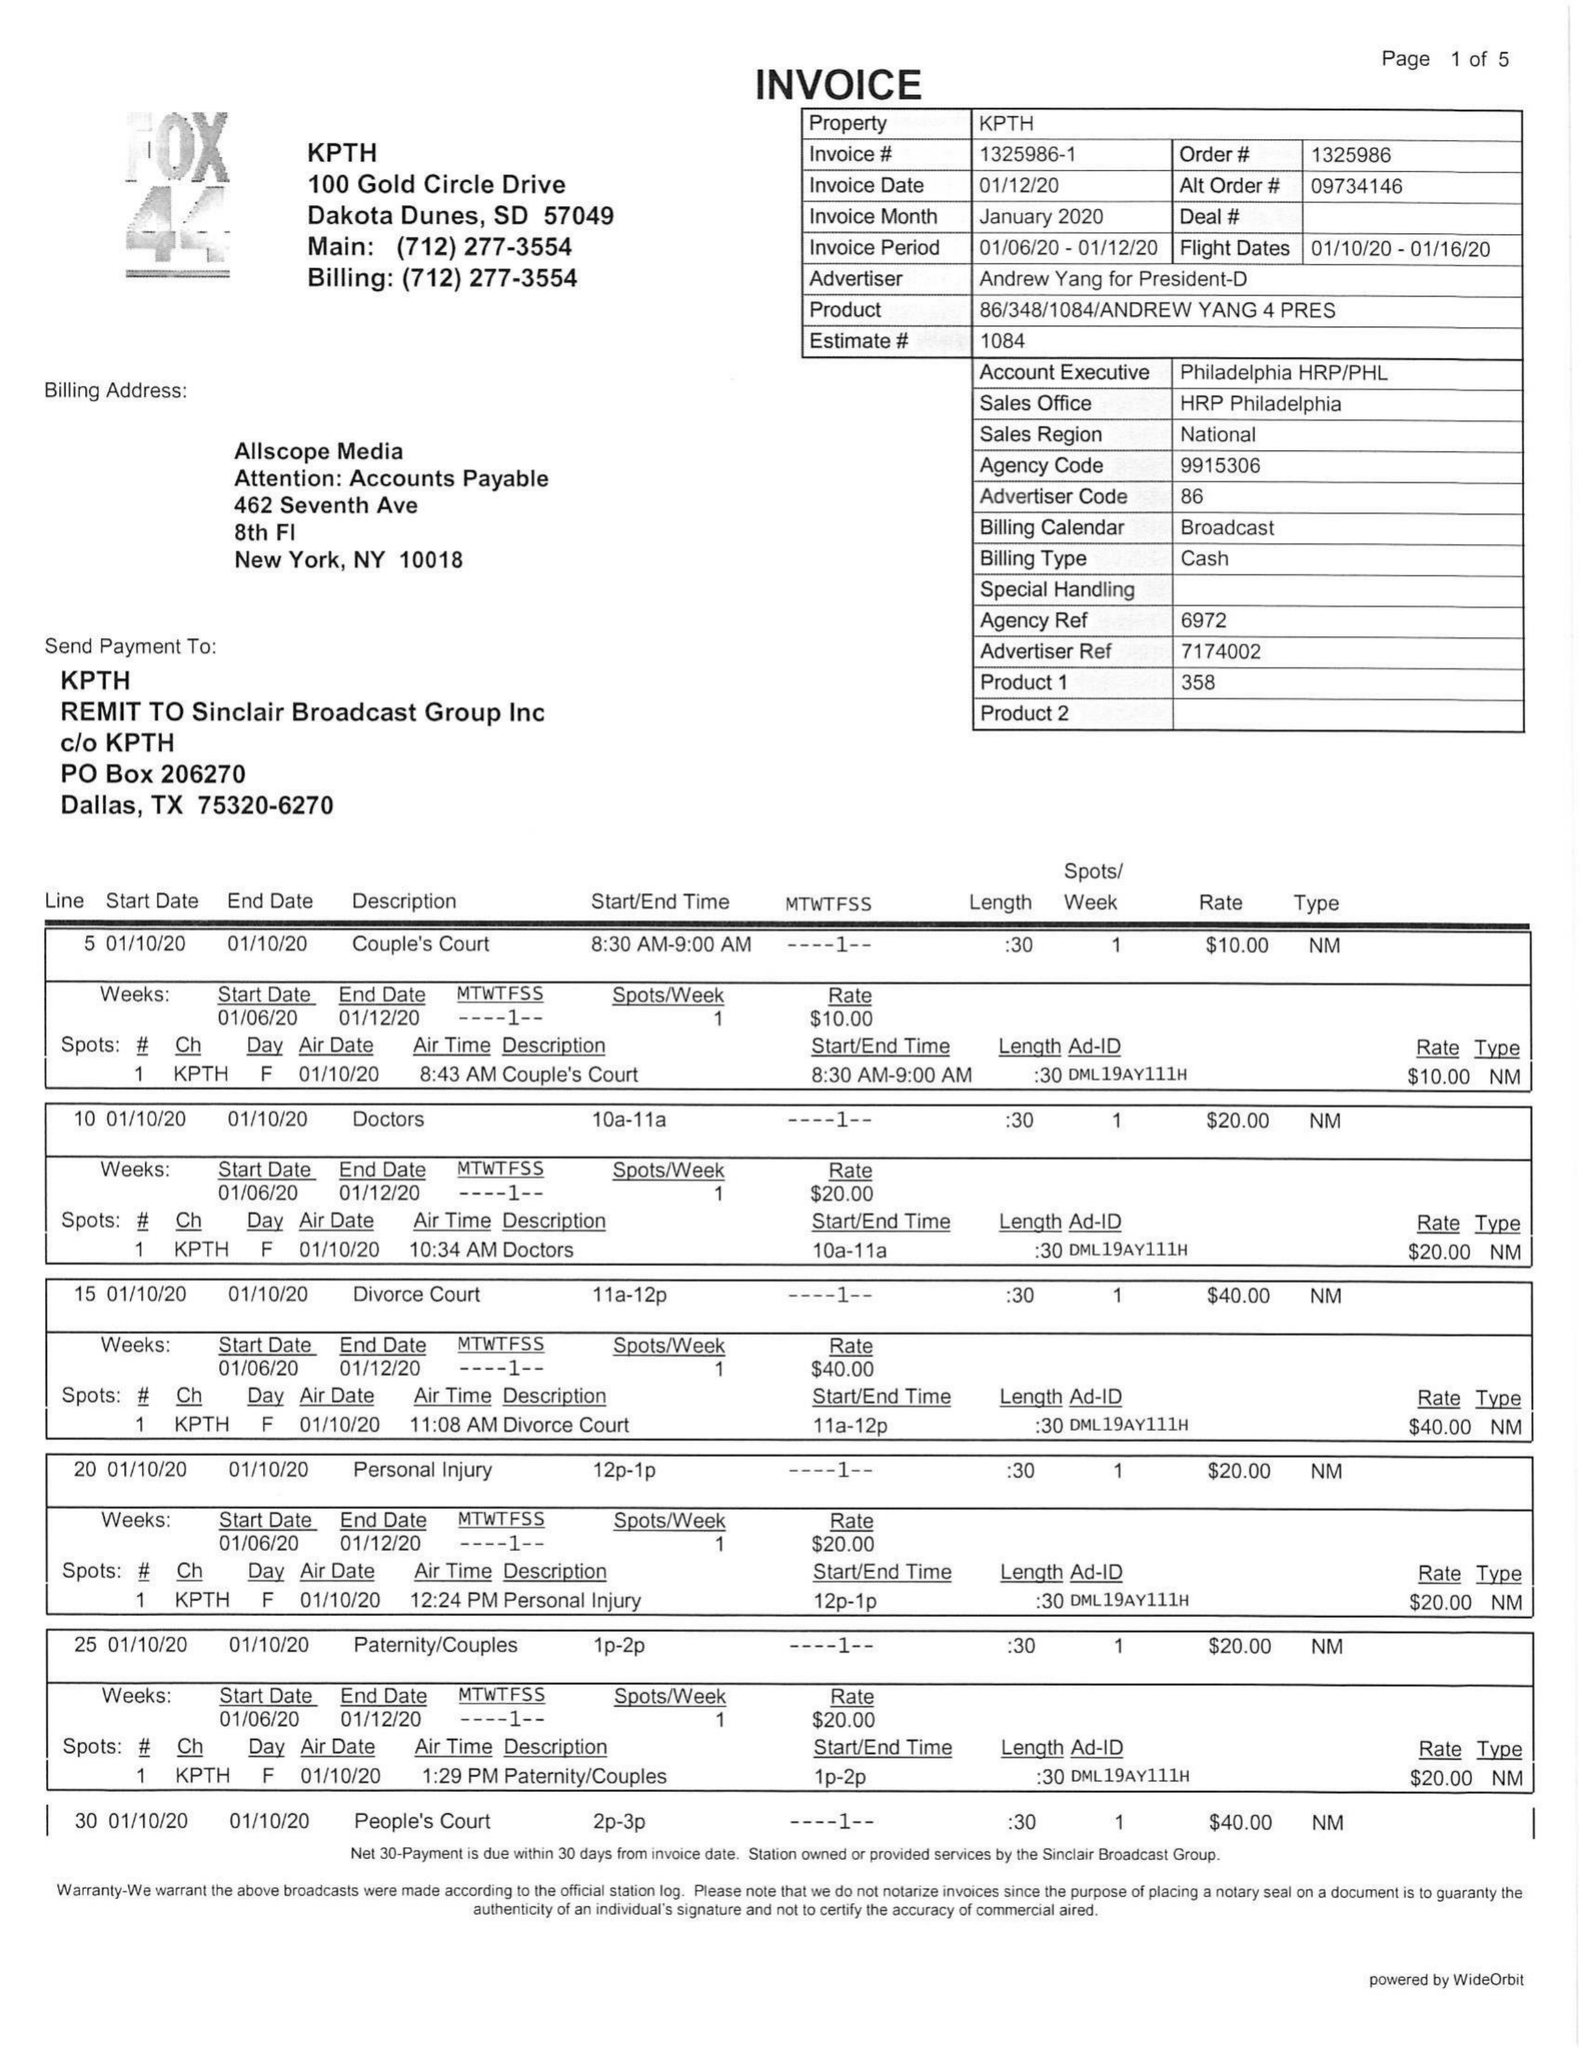What is the value for the advertiser?
Answer the question using a single word or phrase. ANDREW YANG FOR PRESIDENT-D 